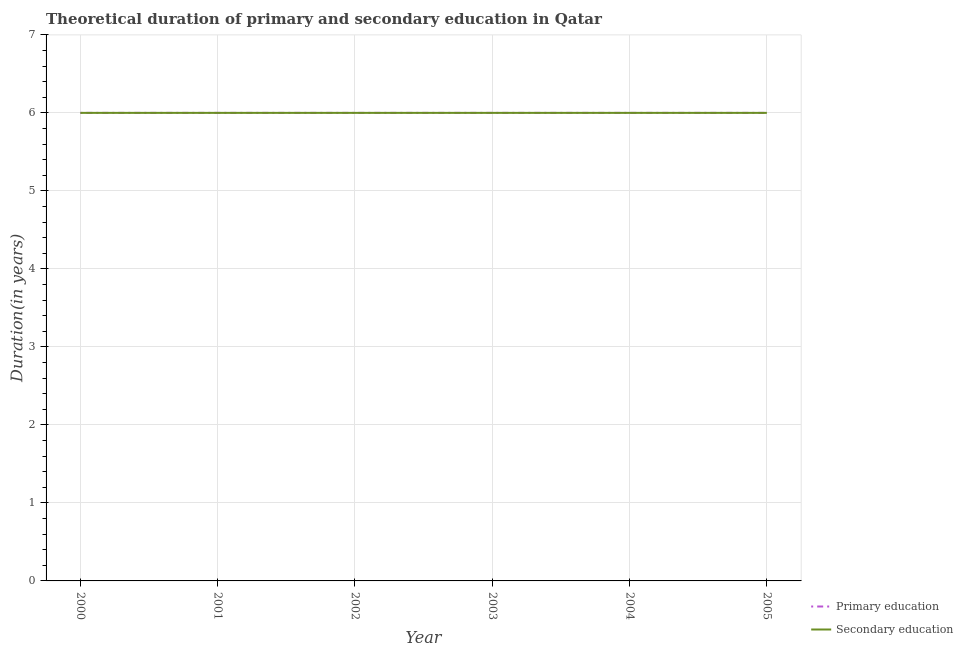Across all years, what is the maximum duration of primary education?
Offer a terse response. 6. Across all years, what is the minimum duration of primary education?
Give a very brief answer. 6. In which year was the duration of secondary education maximum?
Your answer should be compact. 2000. What is the total duration of primary education in the graph?
Ensure brevity in your answer.  36. What is the difference between the duration of secondary education in 2000 and that in 2003?
Give a very brief answer. 0. What is the average duration of secondary education per year?
Your answer should be compact. 6. In the year 2000, what is the difference between the duration of primary education and duration of secondary education?
Give a very brief answer. 0. Is the duration of secondary education in 2004 less than that in 2005?
Your answer should be very brief. No. Is the sum of the duration of primary education in 2002 and 2003 greater than the maximum duration of secondary education across all years?
Provide a short and direct response. Yes. Does the duration of secondary education monotonically increase over the years?
Offer a terse response. No. Is the duration of primary education strictly greater than the duration of secondary education over the years?
Offer a very short reply. No. Is the duration of secondary education strictly less than the duration of primary education over the years?
Your response must be concise. No. How many lines are there?
Your answer should be very brief. 2. What is the difference between two consecutive major ticks on the Y-axis?
Ensure brevity in your answer.  1. Are the values on the major ticks of Y-axis written in scientific E-notation?
Give a very brief answer. No. Does the graph contain grids?
Provide a short and direct response. Yes. Where does the legend appear in the graph?
Make the answer very short. Bottom right. How many legend labels are there?
Ensure brevity in your answer.  2. What is the title of the graph?
Keep it short and to the point. Theoretical duration of primary and secondary education in Qatar. Does "Girls" appear as one of the legend labels in the graph?
Give a very brief answer. No. What is the label or title of the X-axis?
Give a very brief answer. Year. What is the label or title of the Y-axis?
Offer a very short reply. Duration(in years). What is the Duration(in years) in Primary education in 2000?
Offer a terse response. 6. What is the Duration(in years) of Secondary education in 2000?
Offer a terse response. 6. What is the Duration(in years) in Primary education in 2001?
Make the answer very short. 6. What is the Duration(in years) of Primary education in 2002?
Keep it short and to the point. 6. What is the Duration(in years) of Secondary education in 2002?
Make the answer very short. 6. What is the Duration(in years) of Primary education in 2003?
Keep it short and to the point. 6. What is the Duration(in years) in Secondary education in 2003?
Provide a short and direct response. 6. What is the Duration(in years) in Primary education in 2004?
Ensure brevity in your answer.  6. What is the Duration(in years) of Secondary education in 2004?
Make the answer very short. 6. What is the Duration(in years) in Secondary education in 2005?
Your response must be concise. 6. Across all years, what is the maximum Duration(in years) of Primary education?
Keep it short and to the point. 6. Across all years, what is the minimum Duration(in years) in Secondary education?
Offer a very short reply. 6. What is the difference between the Duration(in years) of Secondary education in 2000 and that in 2001?
Offer a very short reply. 0. What is the difference between the Duration(in years) of Primary education in 2000 and that in 2002?
Your answer should be very brief. 0. What is the difference between the Duration(in years) of Secondary education in 2000 and that in 2003?
Give a very brief answer. 0. What is the difference between the Duration(in years) in Secondary education in 2000 and that in 2004?
Make the answer very short. 0. What is the difference between the Duration(in years) in Primary education in 2000 and that in 2005?
Provide a succinct answer. 0. What is the difference between the Duration(in years) of Secondary education in 2000 and that in 2005?
Give a very brief answer. 0. What is the difference between the Duration(in years) of Primary education in 2001 and that in 2003?
Offer a terse response. 0. What is the difference between the Duration(in years) in Secondary education in 2001 and that in 2003?
Offer a very short reply. 0. What is the difference between the Duration(in years) of Primary education in 2001 and that in 2004?
Offer a terse response. 0. What is the difference between the Duration(in years) of Secondary education in 2003 and that in 2004?
Keep it short and to the point. 0. What is the difference between the Duration(in years) in Primary education in 2003 and that in 2005?
Your answer should be compact. 0. What is the difference between the Duration(in years) of Primary education in 2004 and that in 2005?
Your answer should be very brief. 0. What is the difference between the Duration(in years) of Primary education in 2000 and the Duration(in years) of Secondary education in 2003?
Your answer should be compact. 0. What is the difference between the Duration(in years) of Primary education in 2001 and the Duration(in years) of Secondary education in 2003?
Make the answer very short. 0. What is the difference between the Duration(in years) in Primary education in 2001 and the Duration(in years) in Secondary education in 2004?
Provide a short and direct response. 0. What is the difference between the Duration(in years) in Primary education in 2002 and the Duration(in years) in Secondary education in 2003?
Make the answer very short. 0. What is the difference between the Duration(in years) in Primary education in 2002 and the Duration(in years) in Secondary education in 2004?
Give a very brief answer. 0. What is the difference between the Duration(in years) of Primary education in 2002 and the Duration(in years) of Secondary education in 2005?
Give a very brief answer. 0. What is the difference between the Duration(in years) of Primary education in 2004 and the Duration(in years) of Secondary education in 2005?
Keep it short and to the point. 0. What is the average Duration(in years) in Primary education per year?
Ensure brevity in your answer.  6. In the year 2001, what is the difference between the Duration(in years) in Primary education and Duration(in years) in Secondary education?
Ensure brevity in your answer.  0. In the year 2003, what is the difference between the Duration(in years) in Primary education and Duration(in years) in Secondary education?
Offer a very short reply. 0. In the year 2004, what is the difference between the Duration(in years) in Primary education and Duration(in years) in Secondary education?
Offer a terse response. 0. In the year 2005, what is the difference between the Duration(in years) in Primary education and Duration(in years) in Secondary education?
Provide a succinct answer. 0. What is the ratio of the Duration(in years) in Secondary education in 2000 to that in 2004?
Ensure brevity in your answer.  1. What is the ratio of the Duration(in years) in Secondary education in 2000 to that in 2005?
Offer a very short reply. 1. What is the ratio of the Duration(in years) of Primary education in 2001 to that in 2002?
Your answer should be compact. 1. What is the ratio of the Duration(in years) of Secondary education in 2001 to that in 2003?
Your answer should be compact. 1. What is the ratio of the Duration(in years) in Secondary education in 2001 to that in 2004?
Offer a very short reply. 1. What is the ratio of the Duration(in years) of Primary education in 2002 to that in 2005?
Your answer should be very brief. 1. What is the ratio of the Duration(in years) in Primary education in 2003 to that in 2004?
Make the answer very short. 1. What is the ratio of the Duration(in years) in Secondary education in 2003 to that in 2004?
Offer a terse response. 1. What is the ratio of the Duration(in years) of Secondary education in 2003 to that in 2005?
Make the answer very short. 1. What is the ratio of the Duration(in years) of Secondary education in 2004 to that in 2005?
Make the answer very short. 1. What is the difference between the highest and the second highest Duration(in years) of Primary education?
Keep it short and to the point. 0. What is the difference between the highest and the lowest Duration(in years) of Secondary education?
Your answer should be very brief. 0. 